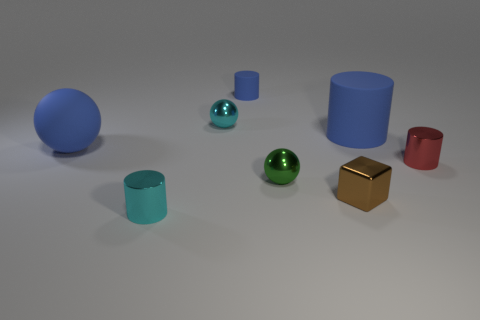Add 1 tiny cyan balls. How many objects exist? 9 Subtract all blocks. How many objects are left? 7 Subtract all large purple cylinders. Subtract all small brown cubes. How many objects are left? 7 Add 2 tiny things. How many tiny things are left? 8 Add 5 small rubber cylinders. How many small rubber cylinders exist? 6 Subtract 2 blue cylinders. How many objects are left? 6 